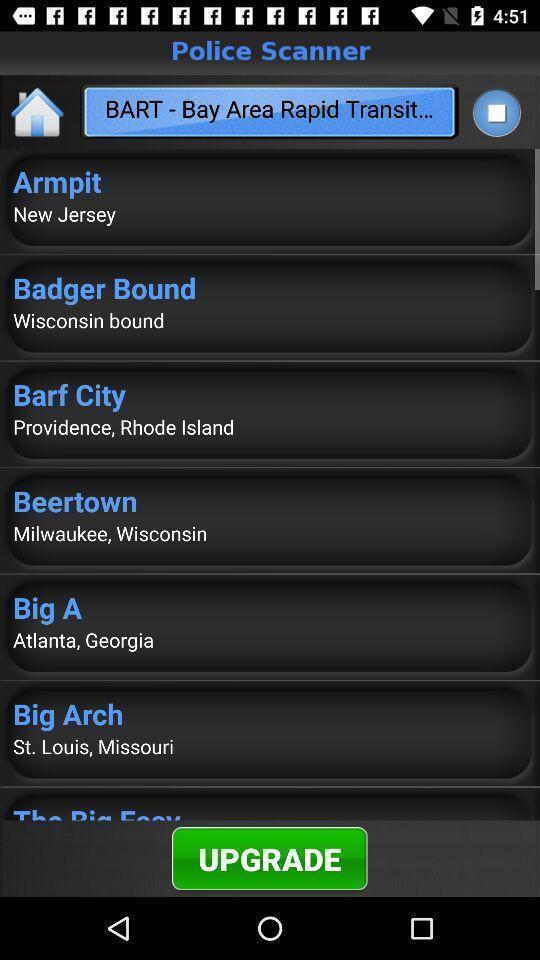Summarize the main components in this picture. Screen displaying page of an rescue application with upgrade option. 